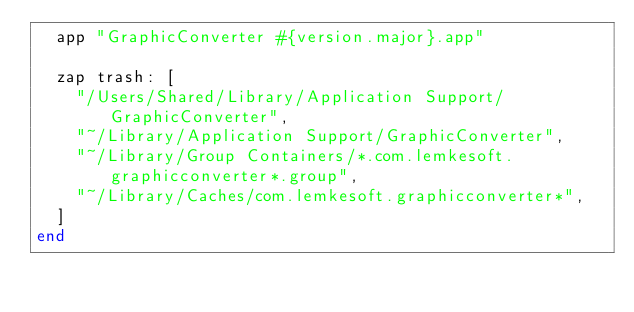Convert code to text. <code><loc_0><loc_0><loc_500><loc_500><_Ruby_>  app "GraphicConverter #{version.major}.app"

  zap trash: [
    "/Users/Shared/Library/Application Support/GraphicConverter",
    "~/Library/Application Support/GraphicConverter",
    "~/Library/Group Containers/*.com.lemkesoft.graphicconverter*.group",
    "~/Library/Caches/com.lemkesoft.graphicconverter*",
  ]
end
</code> 